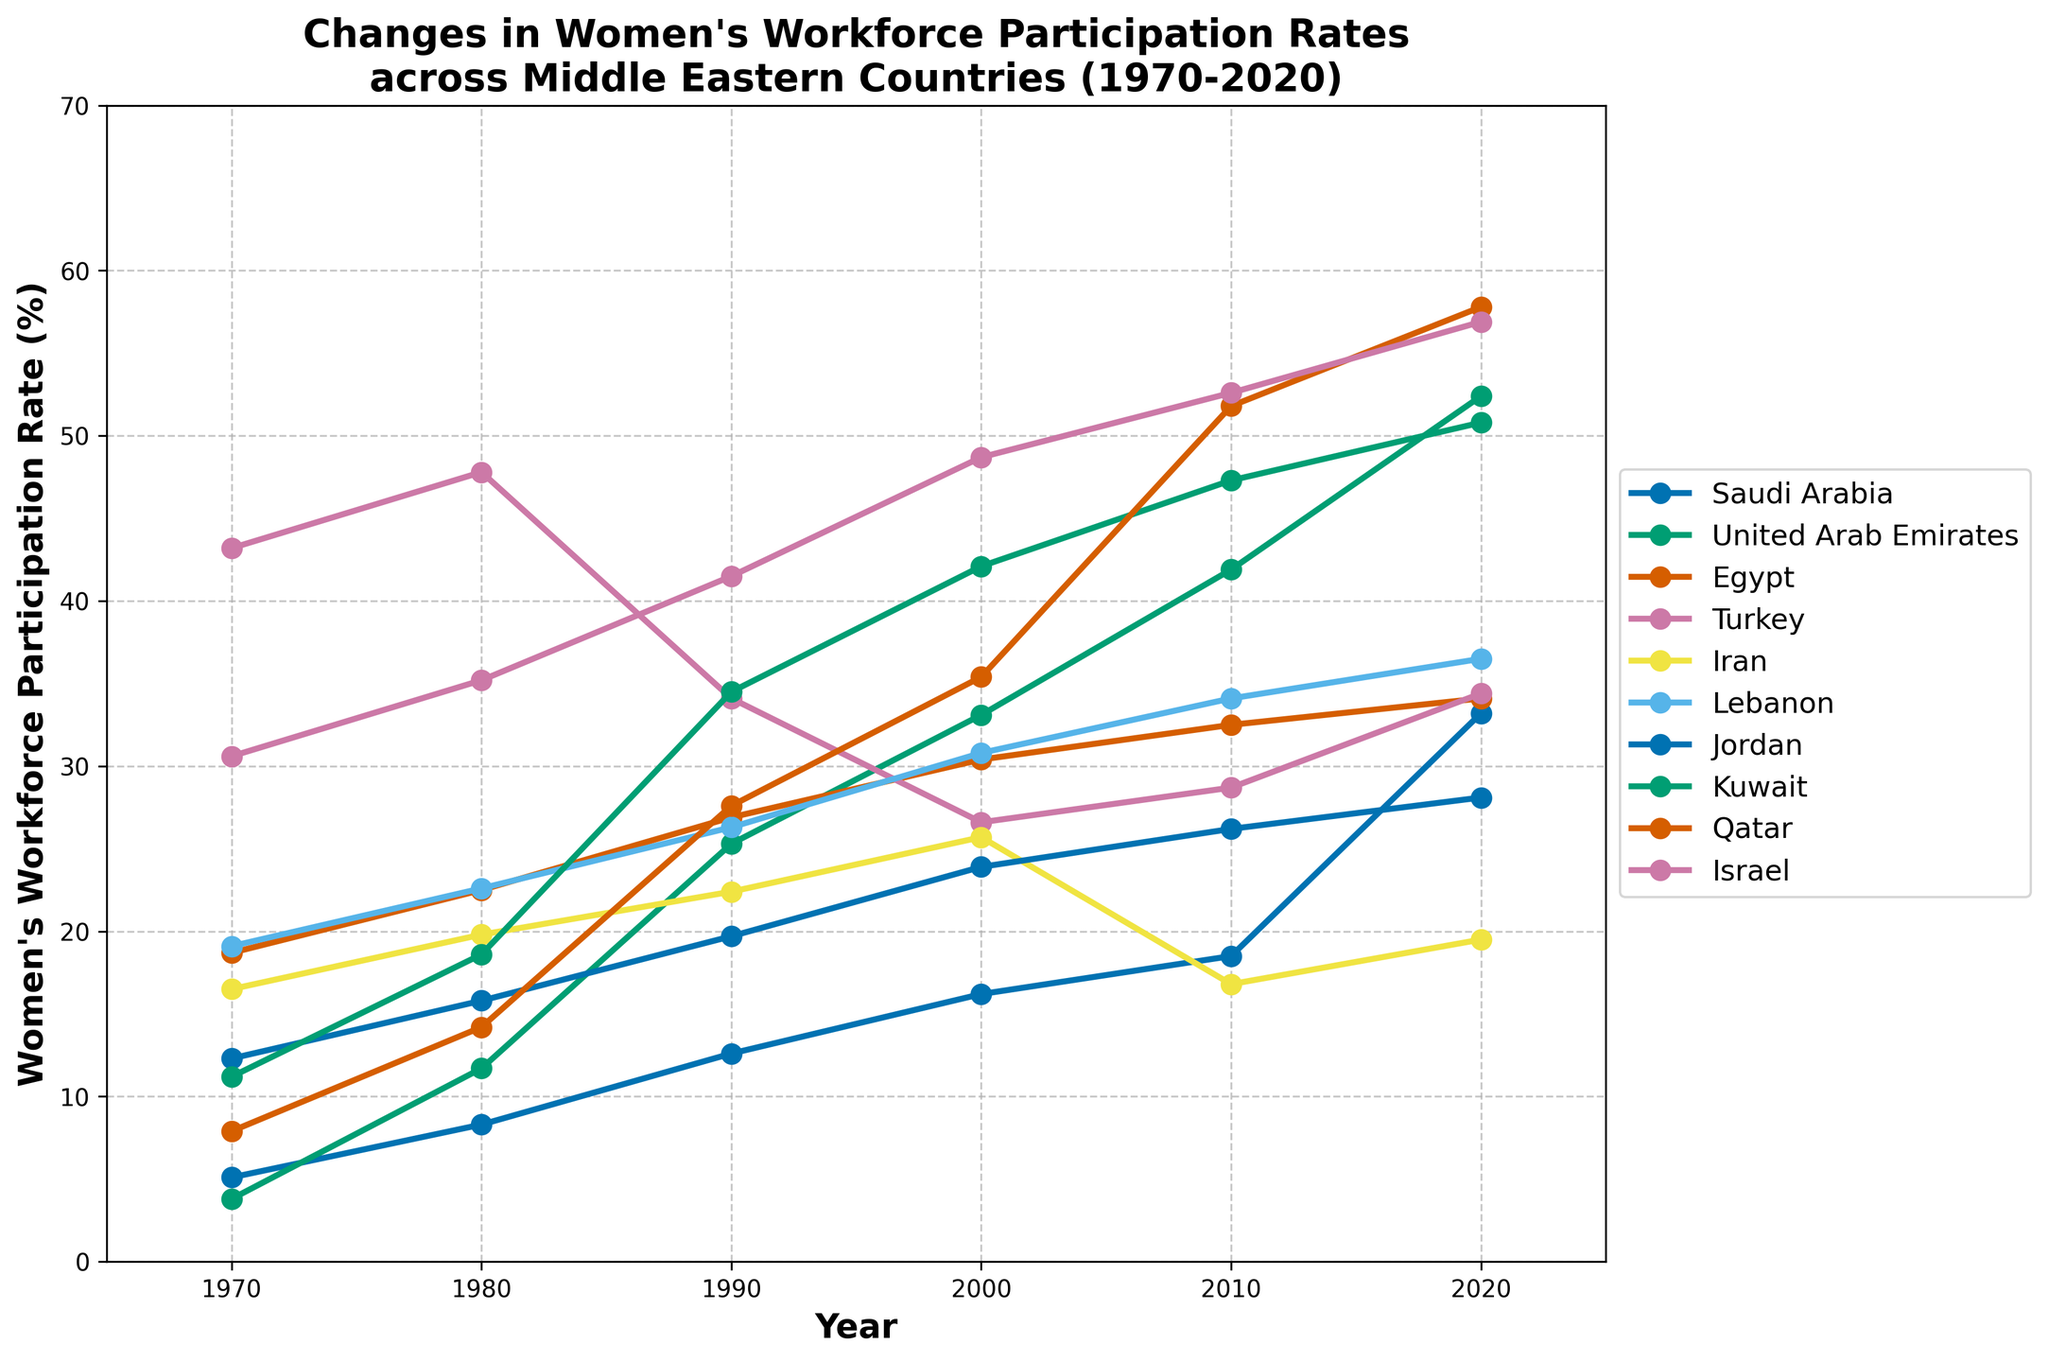Which country had the highest women's workforce participation rate in 2020? The data shows different countries and their participation rates for each decade. In 2020, Qatar had the highest participation rate.
Answer: Qatar Which country shows a consistent increase in women's workforce participation rates from 1970 to 2020? By examining the trends for each country, United Arab Emirates shows a consistent increase in the participation rate across all measured years.
Answer: United Arab Emirates What is the average women's workforce participation rate for Egypt over the 50 years? To find the average, add up the rates for 1970 (18.7), 1980 (22.5), 1990 (26.9), 2000 (30.4), 2010 (32.5), and 2020 (34.1), then divide by the number of data points (6). (18.7 + 22.5 + 26.9 + 30.4 + 32.5 + 34.1) / 6 = 165.1 / 6 = 27.52
Answer: 27.52 Which country had the largest increase in women's workforce participation rate between 2010 and 2020? Calculate the difference between the rates for 2010 and 2020 for each country. United Arab Emirates increased from 41.9 to 52.4, which is an increase of 10.5, the highest among the listed countries.
Answer: United Arab Emirates Which countries had a decrease in women's workforce participation rate at any point during the 50 years? Look at the trends for each country. Turkey shows a decrease from 47.8 in 1980 to 34.1 in 1990, and Iran shows a decrease from 25.7 in 2000 to 16.8 in 2010.
Answer: Turkey, Iran Between which decade did Saudi Arabia see the largest growth in women's workforce participation? To find the largest growth, look at the differences between consecutive decades for Saudi Arabia. The largest growth was from 18.5 in 2010 to 33.2 in 2020, which is a difference of 14.7.
Answer: 2010 to 2020 Which country had a higher women's workforce participation rate in 1990, Kuwait or Egypt? By comparing the values in 1990, Kuwait had a rate of 34.5 while Egypt had 26.9. Therefore, Kuwait had a higher rate.
Answer: Kuwait What is the average rate of change in women's workforce participation for Lebanon from 1970 to 2020? Find the differences for each decade first: (22.6 - 19.1) = 3.5, (26.3 - 22.6) = 3.7, (30.8 - 26.3) = 4.5, (34.1 - 30.8) = 3.3, (36.5 - 34.1) = 2.4. Sum these changes and divide by the number of periods (5). (3.5 + 3.7 + 4.5 + 3.3 + 2.4) / 5 = 17.4 / 5 = 3.48
Answer: 3.48 